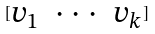<formula> <loc_0><loc_0><loc_500><loc_500>[ \begin{matrix} v _ { 1 } & \cdot \cdot \cdot & v _ { k } \end{matrix} ]</formula> 